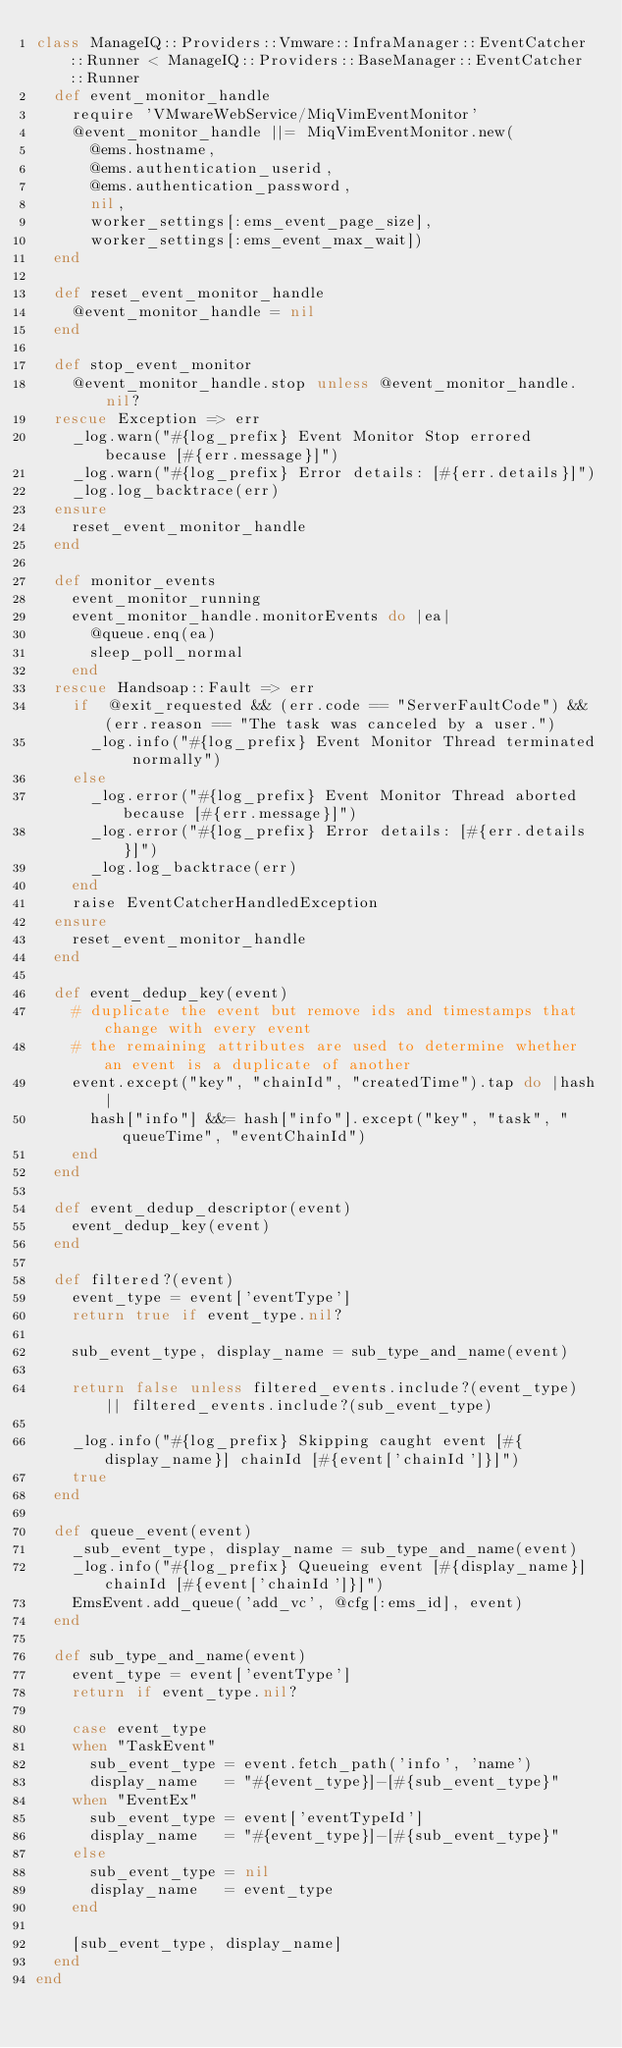Convert code to text. <code><loc_0><loc_0><loc_500><loc_500><_Ruby_>class ManageIQ::Providers::Vmware::InfraManager::EventCatcher::Runner < ManageIQ::Providers::BaseManager::EventCatcher::Runner
  def event_monitor_handle
    require 'VMwareWebService/MiqVimEventMonitor'
    @event_monitor_handle ||= MiqVimEventMonitor.new(
      @ems.hostname,
      @ems.authentication_userid,
      @ems.authentication_password,
      nil,
      worker_settings[:ems_event_page_size],
      worker_settings[:ems_event_max_wait])
  end

  def reset_event_monitor_handle
    @event_monitor_handle = nil
  end

  def stop_event_monitor
    @event_monitor_handle.stop unless @event_monitor_handle.nil?
  rescue Exception => err
    _log.warn("#{log_prefix} Event Monitor Stop errored because [#{err.message}]")
    _log.warn("#{log_prefix} Error details: [#{err.details}]")
    _log.log_backtrace(err)
  ensure
    reset_event_monitor_handle
  end

  def monitor_events
    event_monitor_running
    event_monitor_handle.monitorEvents do |ea|
      @queue.enq(ea)
      sleep_poll_normal
    end
  rescue Handsoap::Fault => err
    if  @exit_requested && (err.code == "ServerFaultCode") && (err.reason == "The task was canceled by a user.")
      _log.info("#{log_prefix} Event Monitor Thread terminated normally")
    else
      _log.error("#{log_prefix} Event Monitor Thread aborted because [#{err.message}]")
      _log.error("#{log_prefix} Error details: [#{err.details}]")
      _log.log_backtrace(err)
    end
    raise EventCatcherHandledException
  ensure
    reset_event_monitor_handle
  end

  def event_dedup_key(event)
    # duplicate the event but remove ids and timestamps that change with every event
    # the remaining attributes are used to determine whether an event is a duplicate of another
    event.except("key", "chainId", "createdTime").tap do |hash|
      hash["info"] &&= hash["info"].except("key", "task", "queueTime", "eventChainId")
    end
  end

  def event_dedup_descriptor(event)
    event_dedup_key(event)
  end

  def filtered?(event)
    event_type = event['eventType']
    return true if event_type.nil?

    sub_event_type, display_name = sub_type_and_name(event)

    return false unless filtered_events.include?(event_type) || filtered_events.include?(sub_event_type)

    _log.info("#{log_prefix} Skipping caught event [#{display_name}] chainId [#{event['chainId']}]")
    true
  end

  def queue_event(event)
    _sub_event_type, display_name = sub_type_and_name(event)
    _log.info("#{log_prefix} Queueing event [#{display_name}] chainId [#{event['chainId']}]")
    EmsEvent.add_queue('add_vc', @cfg[:ems_id], event)
  end

  def sub_type_and_name(event)
    event_type = event['eventType']
    return if event_type.nil?

    case event_type
    when "TaskEvent"
      sub_event_type = event.fetch_path('info', 'name')
      display_name   = "#{event_type}]-[#{sub_event_type}"
    when "EventEx"
      sub_event_type = event['eventTypeId']
      display_name   = "#{event_type}]-[#{sub_event_type}"
    else
      sub_event_type = nil
      display_name   = event_type
    end

    [sub_event_type, display_name]
  end
end
</code> 